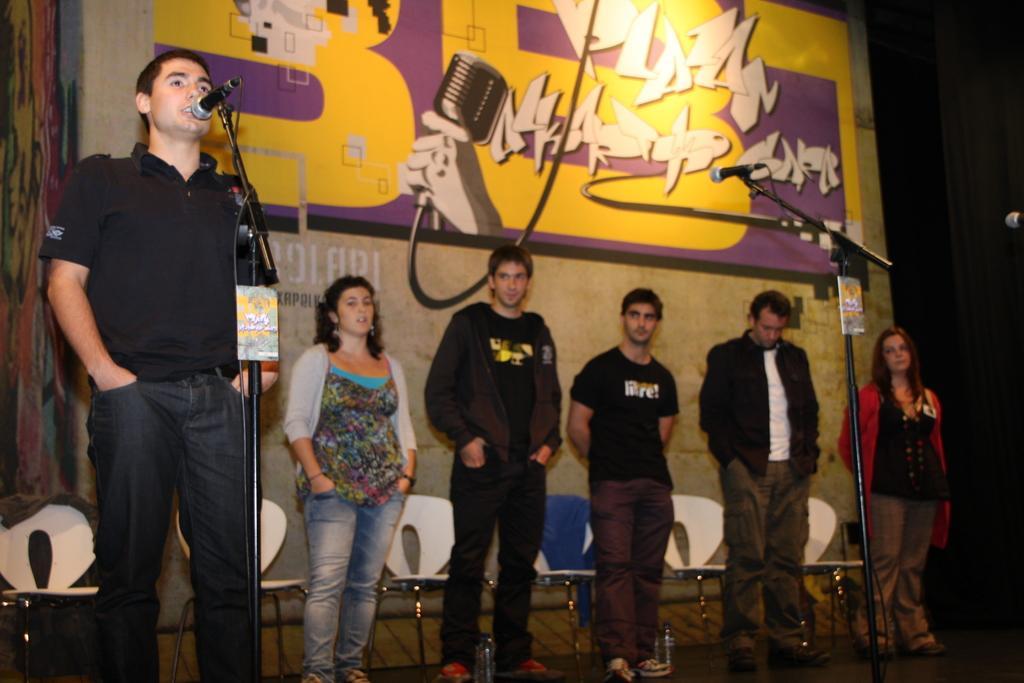Please provide a concise description of this image. In the image I can see a person who is standing in front of the mic and to the side there are some other people and also I can see a banner and a mic. 